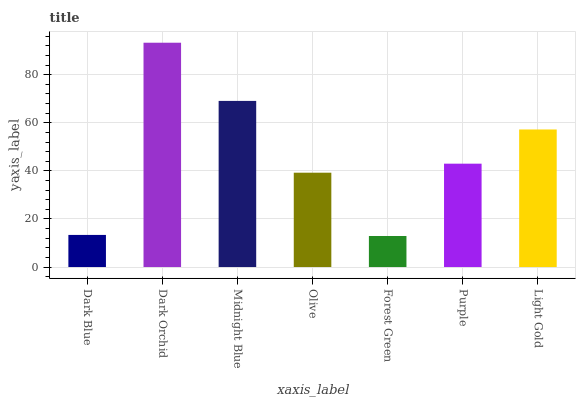Is Forest Green the minimum?
Answer yes or no. Yes. Is Dark Orchid the maximum?
Answer yes or no. Yes. Is Midnight Blue the minimum?
Answer yes or no. No. Is Midnight Blue the maximum?
Answer yes or no. No. Is Dark Orchid greater than Midnight Blue?
Answer yes or no. Yes. Is Midnight Blue less than Dark Orchid?
Answer yes or no. Yes. Is Midnight Blue greater than Dark Orchid?
Answer yes or no. No. Is Dark Orchid less than Midnight Blue?
Answer yes or no. No. Is Purple the high median?
Answer yes or no. Yes. Is Purple the low median?
Answer yes or no. Yes. Is Dark Orchid the high median?
Answer yes or no. No. Is Midnight Blue the low median?
Answer yes or no. No. 